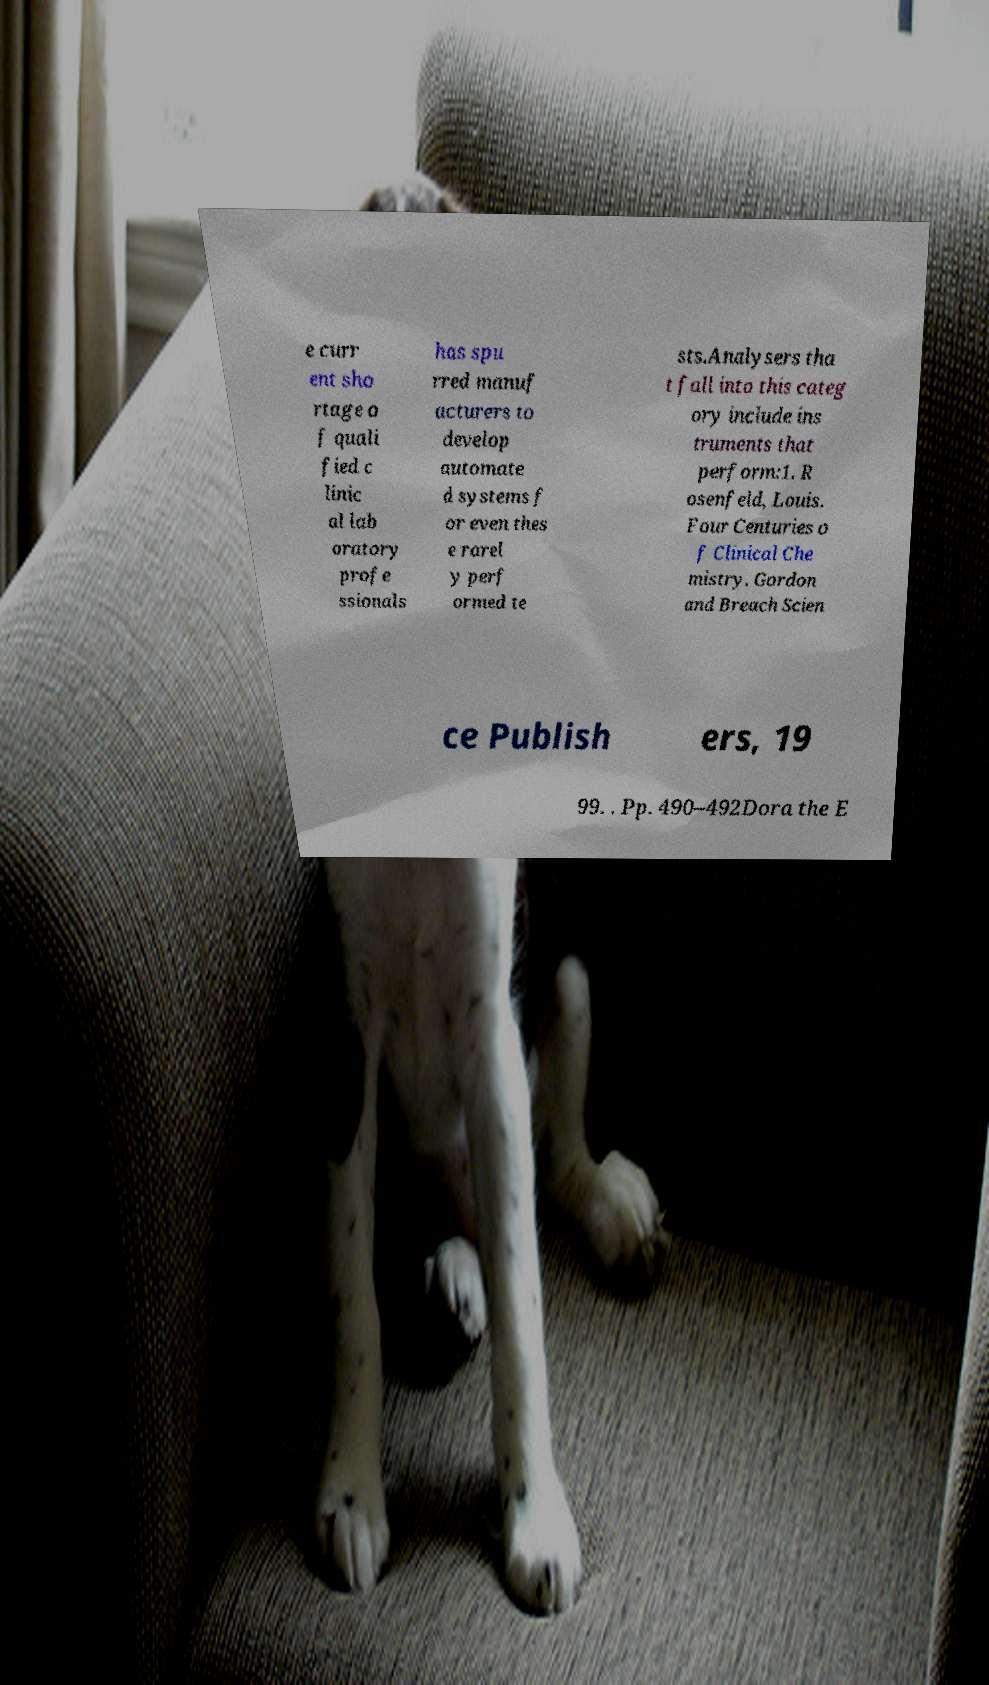Please identify and transcribe the text found in this image. e curr ent sho rtage o f quali fied c linic al lab oratory profe ssionals has spu rred manuf acturers to develop automate d systems f or even thes e rarel y perf ormed te sts.Analysers tha t fall into this categ ory include ins truments that perform:1. R osenfeld, Louis. Four Centuries o f Clinical Che mistry. Gordon and Breach Scien ce Publish ers, 19 99. . Pp. 490–492Dora the E 